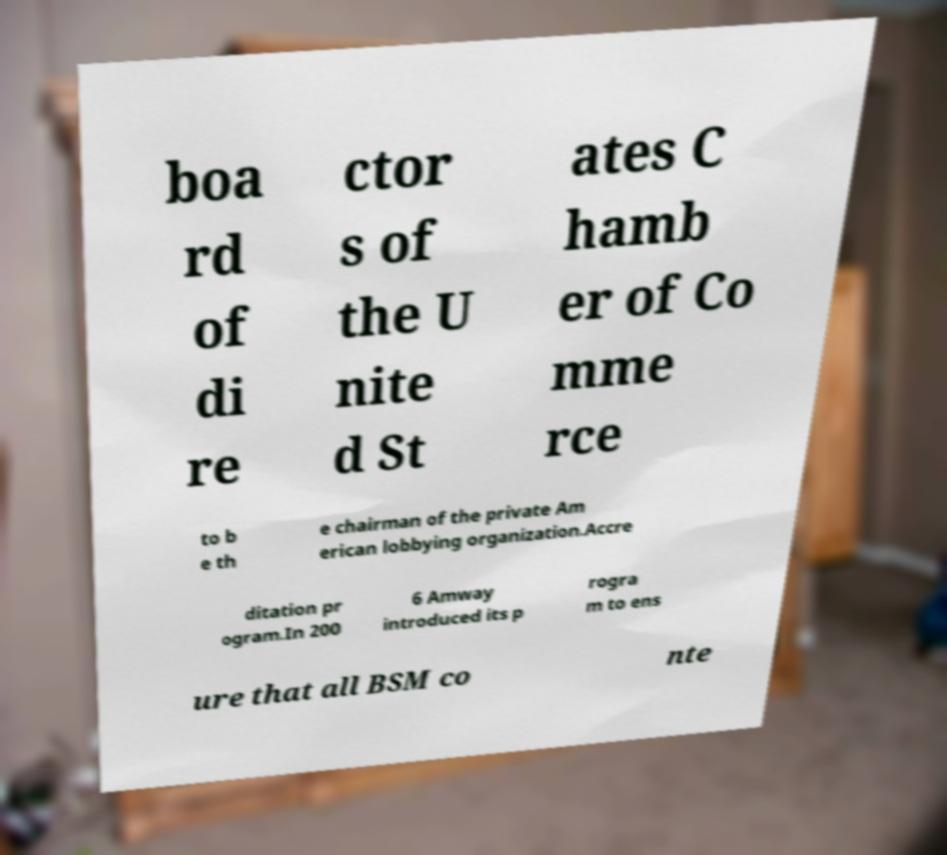What messages or text are displayed in this image? I need them in a readable, typed format. boa rd of di re ctor s of the U nite d St ates C hamb er of Co mme rce to b e th e chairman of the private Am erican lobbying organization.Accre ditation pr ogram.In 200 6 Amway introduced its p rogra m to ens ure that all BSM co nte 